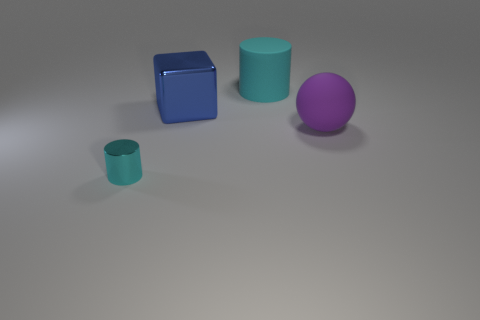The matte thing that is the same color as the tiny shiny thing is what size?
Keep it short and to the point. Large. What number of objects are either shiny cylinders or objects in front of the purple ball?
Offer a very short reply. 1. Are there any small blue cylinders that have the same material as the big purple thing?
Offer a very short reply. No. What number of objects are both to the right of the metal cylinder and on the left side of the sphere?
Make the answer very short. 2. What material is the cylinder behind the large purple rubber sphere?
Keep it short and to the point. Rubber. What is the size of the cyan object that is made of the same material as the sphere?
Your response must be concise. Large. Are there any rubber cylinders in front of the big cyan matte object?
Make the answer very short. No. There is another rubber thing that is the same shape as the tiny cyan object; what is its size?
Offer a terse response. Large. Does the big metallic thing have the same color as the matte object on the right side of the big cyan cylinder?
Offer a terse response. No. Do the tiny thing and the big shiny block have the same color?
Provide a short and direct response. No. 